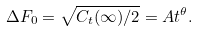<formula> <loc_0><loc_0><loc_500><loc_500>\Delta F _ { 0 } = \sqrt { C _ { t } ( \infty ) / 2 } = A t ^ { \theta } .</formula> 